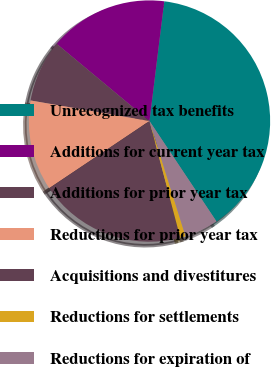<chart> <loc_0><loc_0><loc_500><loc_500><pie_chart><fcel>Unrecognized tax benefits<fcel>Additions for current year tax<fcel>Additions for prior year tax<fcel>Reductions for prior year tax<fcel>Acquisitions and divestitures<fcel>Reductions for settlements<fcel>Reductions for expiration of<nl><fcel>38.68%<fcel>15.91%<fcel>8.32%<fcel>12.12%<fcel>19.71%<fcel>0.73%<fcel>4.53%<nl></chart> 